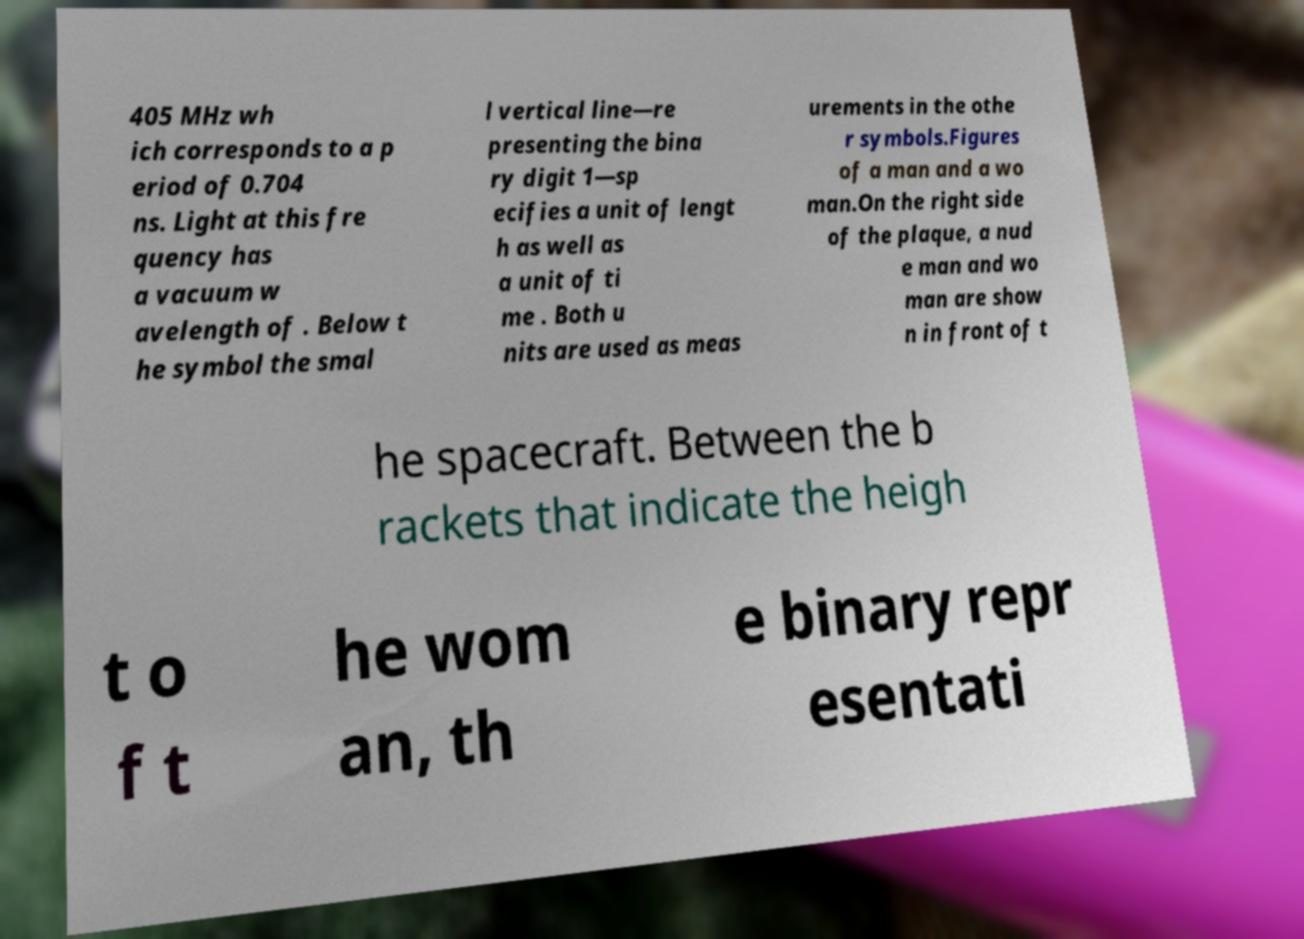For documentation purposes, I need the text within this image transcribed. Could you provide that? 405 MHz wh ich corresponds to a p eriod of 0.704 ns. Light at this fre quency has a vacuum w avelength of . Below t he symbol the smal l vertical line—re presenting the bina ry digit 1—sp ecifies a unit of lengt h as well as a unit of ti me . Both u nits are used as meas urements in the othe r symbols.Figures of a man and a wo man.On the right side of the plaque, a nud e man and wo man are show n in front of t he spacecraft. Between the b rackets that indicate the heigh t o f t he wom an, th e binary repr esentati 